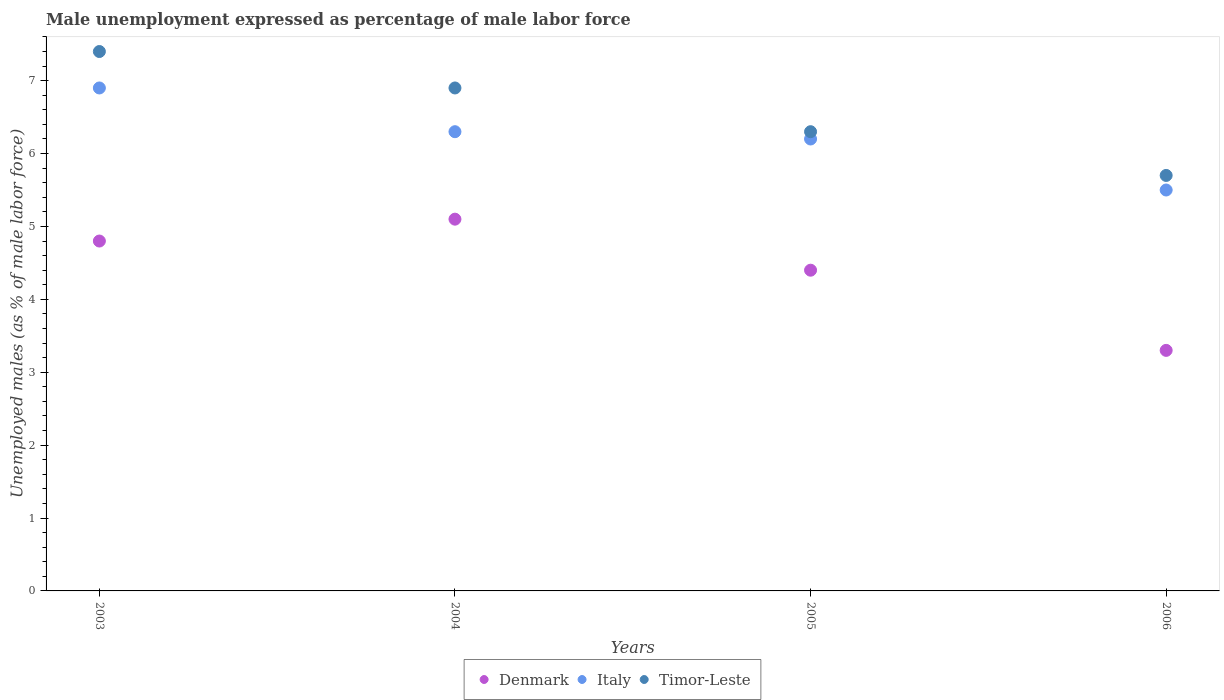How many different coloured dotlines are there?
Offer a terse response. 3. What is the unemployment in males in in Italy in 2006?
Give a very brief answer. 5.5. Across all years, what is the maximum unemployment in males in in Italy?
Ensure brevity in your answer.  6.9. Across all years, what is the minimum unemployment in males in in Italy?
Your response must be concise. 5.5. What is the total unemployment in males in in Italy in the graph?
Your answer should be very brief. 24.9. What is the difference between the unemployment in males in in Italy in 2004 and that in 2005?
Your answer should be very brief. 0.1. What is the difference between the unemployment in males in in Timor-Leste in 2004 and the unemployment in males in in Denmark in 2003?
Provide a succinct answer. 2.1. What is the average unemployment in males in in Italy per year?
Provide a short and direct response. 6.23. In the year 2006, what is the difference between the unemployment in males in in Denmark and unemployment in males in in Italy?
Provide a short and direct response. -2.2. In how many years, is the unemployment in males in in Denmark greater than 5 %?
Ensure brevity in your answer.  1. What is the ratio of the unemployment in males in in Italy in 2003 to that in 2006?
Provide a short and direct response. 1.25. Is the unemployment in males in in Denmark in 2003 less than that in 2005?
Keep it short and to the point. No. Is the difference between the unemployment in males in in Denmark in 2004 and 2005 greater than the difference between the unemployment in males in in Italy in 2004 and 2005?
Offer a terse response. Yes. What is the difference between the highest and the second highest unemployment in males in in Italy?
Your response must be concise. 0.6. What is the difference between the highest and the lowest unemployment in males in in Italy?
Ensure brevity in your answer.  1.4. In how many years, is the unemployment in males in in Denmark greater than the average unemployment in males in in Denmark taken over all years?
Your answer should be compact. 3. Is the sum of the unemployment in males in in Timor-Leste in 2004 and 2005 greater than the maximum unemployment in males in in Italy across all years?
Ensure brevity in your answer.  Yes. Does the unemployment in males in in Denmark monotonically increase over the years?
Offer a terse response. No. How many dotlines are there?
Your response must be concise. 3. Does the graph contain any zero values?
Make the answer very short. No. Where does the legend appear in the graph?
Make the answer very short. Bottom center. How many legend labels are there?
Offer a very short reply. 3. How are the legend labels stacked?
Provide a short and direct response. Horizontal. What is the title of the graph?
Your answer should be compact. Male unemployment expressed as percentage of male labor force. What is the label or title of the X-axis?
Offer a terse response. Years. What is the label or title of the Y-axis?
Offer a very short reply. Unemployed males (as % of male labor force). What is the Unemployed males (as % of male labor force) of Denmark in 2003?
Offer a very short reply. 4.8. What is the Unemployed males (as % of male labor force) of Italy in 2003?
Provide a short and direct response. 6.9. What is the Unemployed males (as % of male labor force) of Timor-Leste in 2003?
Offer a terse response. 7.4. What is the Unemployed males (as % of male labor force) of Denmark in 2004?
Ensure brevity in your answer.  5.1. What is the Unemployed males (as % of male labor force) of Italy in 2004?
Ensure brevity in your answer.  6.3. What is the Unemployed males (as % of male labor force) in Timor-Leste in 2004?
Your answer should be very brief. 6.9. What is the Unemployed males (as % of male labor force) of Denmark in 2005?
Provide a succinct answer. 4.4. What is the Unemployed males (as % of male labor force) of Italy in 2005?
Provide a short and direct response. 6.2. What is the Unemployed males (as % of male labor force) in Timor-Leste in 2005?
Provide a short and direct response. 6.3. What is the Unemployed males (as % of male labor force) of Denmark in 2006?
Your response must be concise. 3.3. What is the Unemployed males (as % of male labor force) of Timor-Leste in 2006?
Offer a terse response. 5.7. Across all years, what is the maximum Unemployed males (as % of male labor force) in Denmark?
Ensure brevity in your answer.  5.1. Across all years, what is the maximum Unemployed males (as % of male labor force) of Italy?
Give a very brief answer. 6.9. Across all years, what is the maximum Unemployed males (as % of male labor force) of Timor-Leste?
Offer a terse response. 7.4. Across all years, what is the minimum Unemployed males (as % of male labor force) of Denmark?
Provide a succinct answer. 3.3. Across all years, what is the minimum Unemployed males (as % of male labor force) in Timor-Leste?
Your answer should be very brief. 5.7. What is the total Unemployed males (as % of male labor force) of Denmark in the graph?
Make the answer very short. 17.6. What is the total Unemployed males (as % of male labor force) in Italy in the graph?
Keep it short and to the point. 24.9. What is the total Unemployed males (as % of male labor force) in Timor-Leste in the graph?
Offer a very short reply. 26.3. What is the difference between the Unemployed males (as % of male labor force) of Timor-Leste in 2003 and that in 2004?
Your answer should be very brief. 0.5. What is the difference between the Unemployed males (as % of male labor force) of Denmark in 2003 and that in 2005?
Your answer should be compact. 0.4. What is the difference between the Unemployed males (as % of male labor force) of Timor-Leste in 2003 and that in 2006?
Provide a succinct answer. 1.7. What is the difference between the Unemployed males (as % of male labor force) of Timor-Leste in 2004 and that in 2005?
Keep it short and to the point. 0.6. What is the difference between the Unemployed males (as % of male labor force) of Denmark in 2004 and that in 2006?
Your response must be concise. 1.8. What is the difference between the Unemployed males (as % of male labor force) in Italy in 2004 and that in 2006?
Your answer should be compact. 0.8. What is the difference between the Unemployed males (as % of male labor force) in Timor-Leste in 2004 and that in 2006?
Offer a very short reply. 1.2. What is the difference between the Unemployed males (as % of male labor force) in Denmark in 2005 and that in 2006?
Offer a very short reply. 1.1. What is the difference between the Unemployed males (as % of male labor force) of Italy in 2005 and that in 2006?
Your answer should be compact. 0.7. What is the difference between the Unemployed males (as % of male labor force) in Denmark in 2003 and the Unemployed males (as % of male labor force) in Timor-Leste in 2004?
Provide a succinct answer. -2.1. What is the difference between the Unemployed males (as % of male labor force) of Italy in 2003 and the Unemployed males (as % of male labor force) of Timor-Leste in 2004?
Ensure brevity in your answer.  0. What is the difference between the Unemployed males (as % of male labor force) of Denmark in 2003 and the Unemployed males (as % of male labor force) of Italy in 2005?
Keep it short and to the point. -1.4. What is the difference between the Unemployed males (as % of male labor force) of Italy in 2003 and the Unemployed males (as % of male labor force) of Timor-Leste in 2005?
Keep it short and to the point. 0.6. What is the difference between the Unemployed males (as % of male labor force) of Denmark in 2003 and the Unemployed males (as % of male labor force) of Timor-Leste in 2006?
Keep it short and to the point. -0.9. What is the difference between the Unemployed males (as % of male labor force) of Italy in 2003 and the Unemployed males (as % of male labor force) of Timor-Leste in 2006?
Ensure brevity in your answer.  1.2. What is the difference between the Unemployed males (as % of male labor force) of Denmark in 2005 and the Unemployed males (as % of male labor force) of Italy in 2006?
Provide a succinct answer. -1.1. What is the difference between the Unemployed males (as % of male labor force) in Denmark in 2005 and the Unemployed males (as % of male labor force) in Timor-Leste in 2006?
Your response must be concise. -1.3. What is the average Unemployed males (as % of male labor force) in Denmark per year?
Make the answer very short. 4.4. What is the average Unemployed males (as % of male labor force) of Italy per year?
Make the answer very short. 6.22. What is the average Unemployed males (as % of male labor force) of Timor-Leste per year?
Offer a very short reply. 6.58. In the year 2003, what is the difference between the Unemployed males (as % of male labor force) of Denmark and Unemployed males (as % of male labor force) of Italy?
Provide a succinct answer. -2.1. In the year 2003, what is the difference between the Unemployed males (as % of male labor force) of Denmark and Unemployed males (as % of male labor force) of Timor-Leste?
Give a very brief answer. -2.6. In the year 2003, what is the difference between the Unemployed males (as % of male labor force) of Italy and Unemployed males (as % of male labor force) of Timor-Leste?
Offer a terse response. -0.5. In the year 2004, what is the difference between the Unemployed males (as % of male labor force) of Denmark and Unemployed males (as % of male labor force) of Italy?
Offer a very short reply. -1.2. In the year 2004, what is the difference between the Unemployed males (as % of male labor force) in Italy and Unemployed males (as % of male labor force) in Timor-Leste?
Offer a very short reply. -0.6. In the year 2005, what is the difference between the Unemployed males (as % of male labor force) of Denmark and Unemployed males (as % of male labor force) of Timor-Leste?
Offer a very short reply. -1.9. What is the ratio of the Unemployed males (as % of male labor force) of Denmark in 2003 to that in 2004?
Ensure brevity in your answer.  0.94. What is the ratio of the Unemployed males (as % of male labor force) of Italy in 2003 to that in 2004?
Provide a succinct answer. 1.1. What is the ratio of the Unemployed males (as % of male labor force) in Timor-Leste in 2003 to that in 2004?
Your answer should be compact. 1.07. What is the ratio of the Unemployed males (as % of male labor force) of Italy in 2003 to that in 2005?
Your response must be concise. 1.11. What is the ratio of the Unemployed males (as % of male labor force) in Timor-Leste in 2003 to that in 2005?
Keep it short and to the point. 1.17. What is the ratio of the Unemployed males (as % of male labor force) in Denmark in 2003 to that in 2006?
Provide a succinct answer. 1.45. What is the ratio of the Unemployed males (as % of male labor force) in Italy in 2003 to that in 2006?
Give a very brief answer. 1.25. What is the ratio of the Unemployed males (as % of male labor force) of Timor-Leste in 2003 to that in 2006?
Provide a short and direct response. 1.3. What is the ratio of the Unemployed males (as % of male labor force) of Denmark in 2004 to that in 2005?
Your answer should be very brief. 1.16. What is the ratio of the Unemployed males (as % of male labor force) in Italy in 2004 to that in 2005?
Provide a short and direct response. 1.02. What is the ratio of the Unemployed males (as % of male labor force) of Timor-Leste in 2004 to that in 2005?
Offer a terse response. 1.1. What is the ratio of the Unemployed males (as % of male labor force) of Denmark in 2004 to that in 2006?
Give a very brief answer. 1.55. What is the ratio of the Unemployed males (as % of male labor force) of Italy in 2004 to that in 2006?
Keep it short and to the point. 1.15. What is the ratio of the Unemployed males (as % of male labor force) in Timor-Leste in 2004 to that in 2006?
Provide a succinct answer. 1.21. What is the ratio of the Unemployed males (as % of male labor force) of Italy in 2005 to that in 2006?
Your answer should be compact. 1.13. What is the ratio of the Unemployed males (as % of male labor force) in Timor-Leste in 2005 to that in 2006?
Your answer should be compact. 1.11. What is the difference between the highest and the second highest Unemployed males (as % of male labor force) of Italy?
Your answer should be very brief. 0.6. What is the difference between the highest and the second highest Unemployed males (as % of male labor force) in Timor-Leste?
Give a very brief answer. 0.5. What is the difference between the highest and the lowest Unemployed males (as % of male labor force) in Italy?
Offer a terse response. 1.4. What is the difference between the highest and the lowest Unemployed males (as % of male labor force) of Timor-Leste?
Your response must be concise. 1.7. 